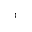<formula> <loc_0><loc_0><loc_500><loc_500>^ { 3 }</formula> 